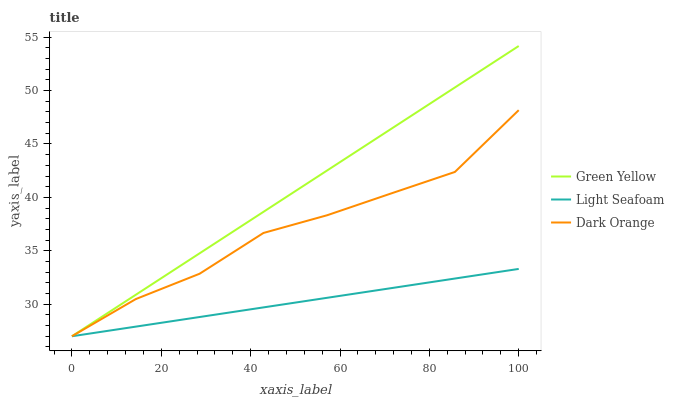Does Light Seafoam have the minimum area under the curve?
Answer yes or no. Yes. Does Green Yellow have the maximum area under the curve?
Answer yes or no. Yes. Does Green Yellow have the minimum area under the curve?
Answer yes or no. No. Does Light Seafoam have the maximum area under the curve?
Answer yes or no. No. Is Light Seafoam the smoothest?
Answer yes or no. Yes. Is Dark Orange the roughest?
Answer yes or no. Yes. Is Green Yellow the smoothest?
Answer yes or no. No. Is Green Yellow the roughest?
Answer yes or no. No. Does Dark Orange have the lowest value?
Answer yes or no. Yes. Does Green Yellow have the highest value?
Answer yes or no. Yes. Does Light Seafoam have the highest value?
Answer yes or no. No. Does Dark Orange intersect Green Yellow?
Answer yes or no. Yes. Is Dark Orange less than Green Yellow?
Answer yes or no. No. Is Dark Orange greater than Green Yellow?
Answer yes or no. No. 